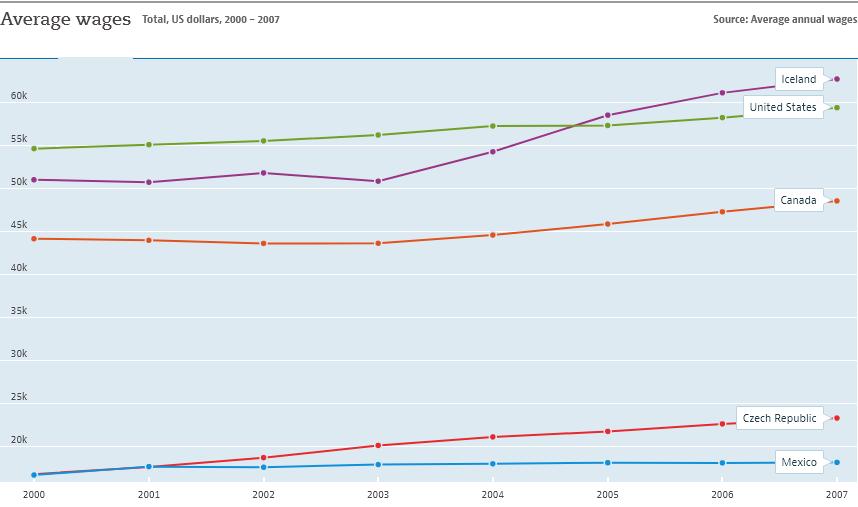Outline some significant characteristics in this image. The average number of Iceland is not larger than that of the US. The color of the line representing the United States is green. 